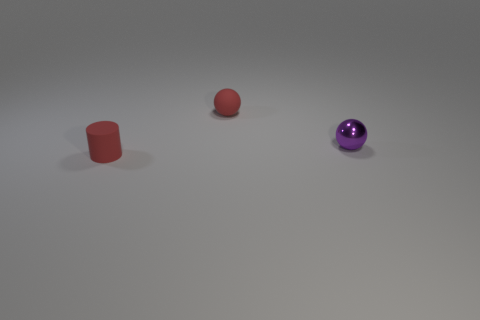Add 3 tiny purple balls. How many objects exist? 6 Subtract all cylinders. How many objects are left? 2 Add 2 cylinders. How many cylinders are left? 3 Add 2 large green matte cubes. How many large green matte cubes exist? 2 Subtract 1 red cylinders. How many objects are left? 2 Subtract all tiny objects. Subtract all tiny blue rubber balls. How many objects are left? 0 